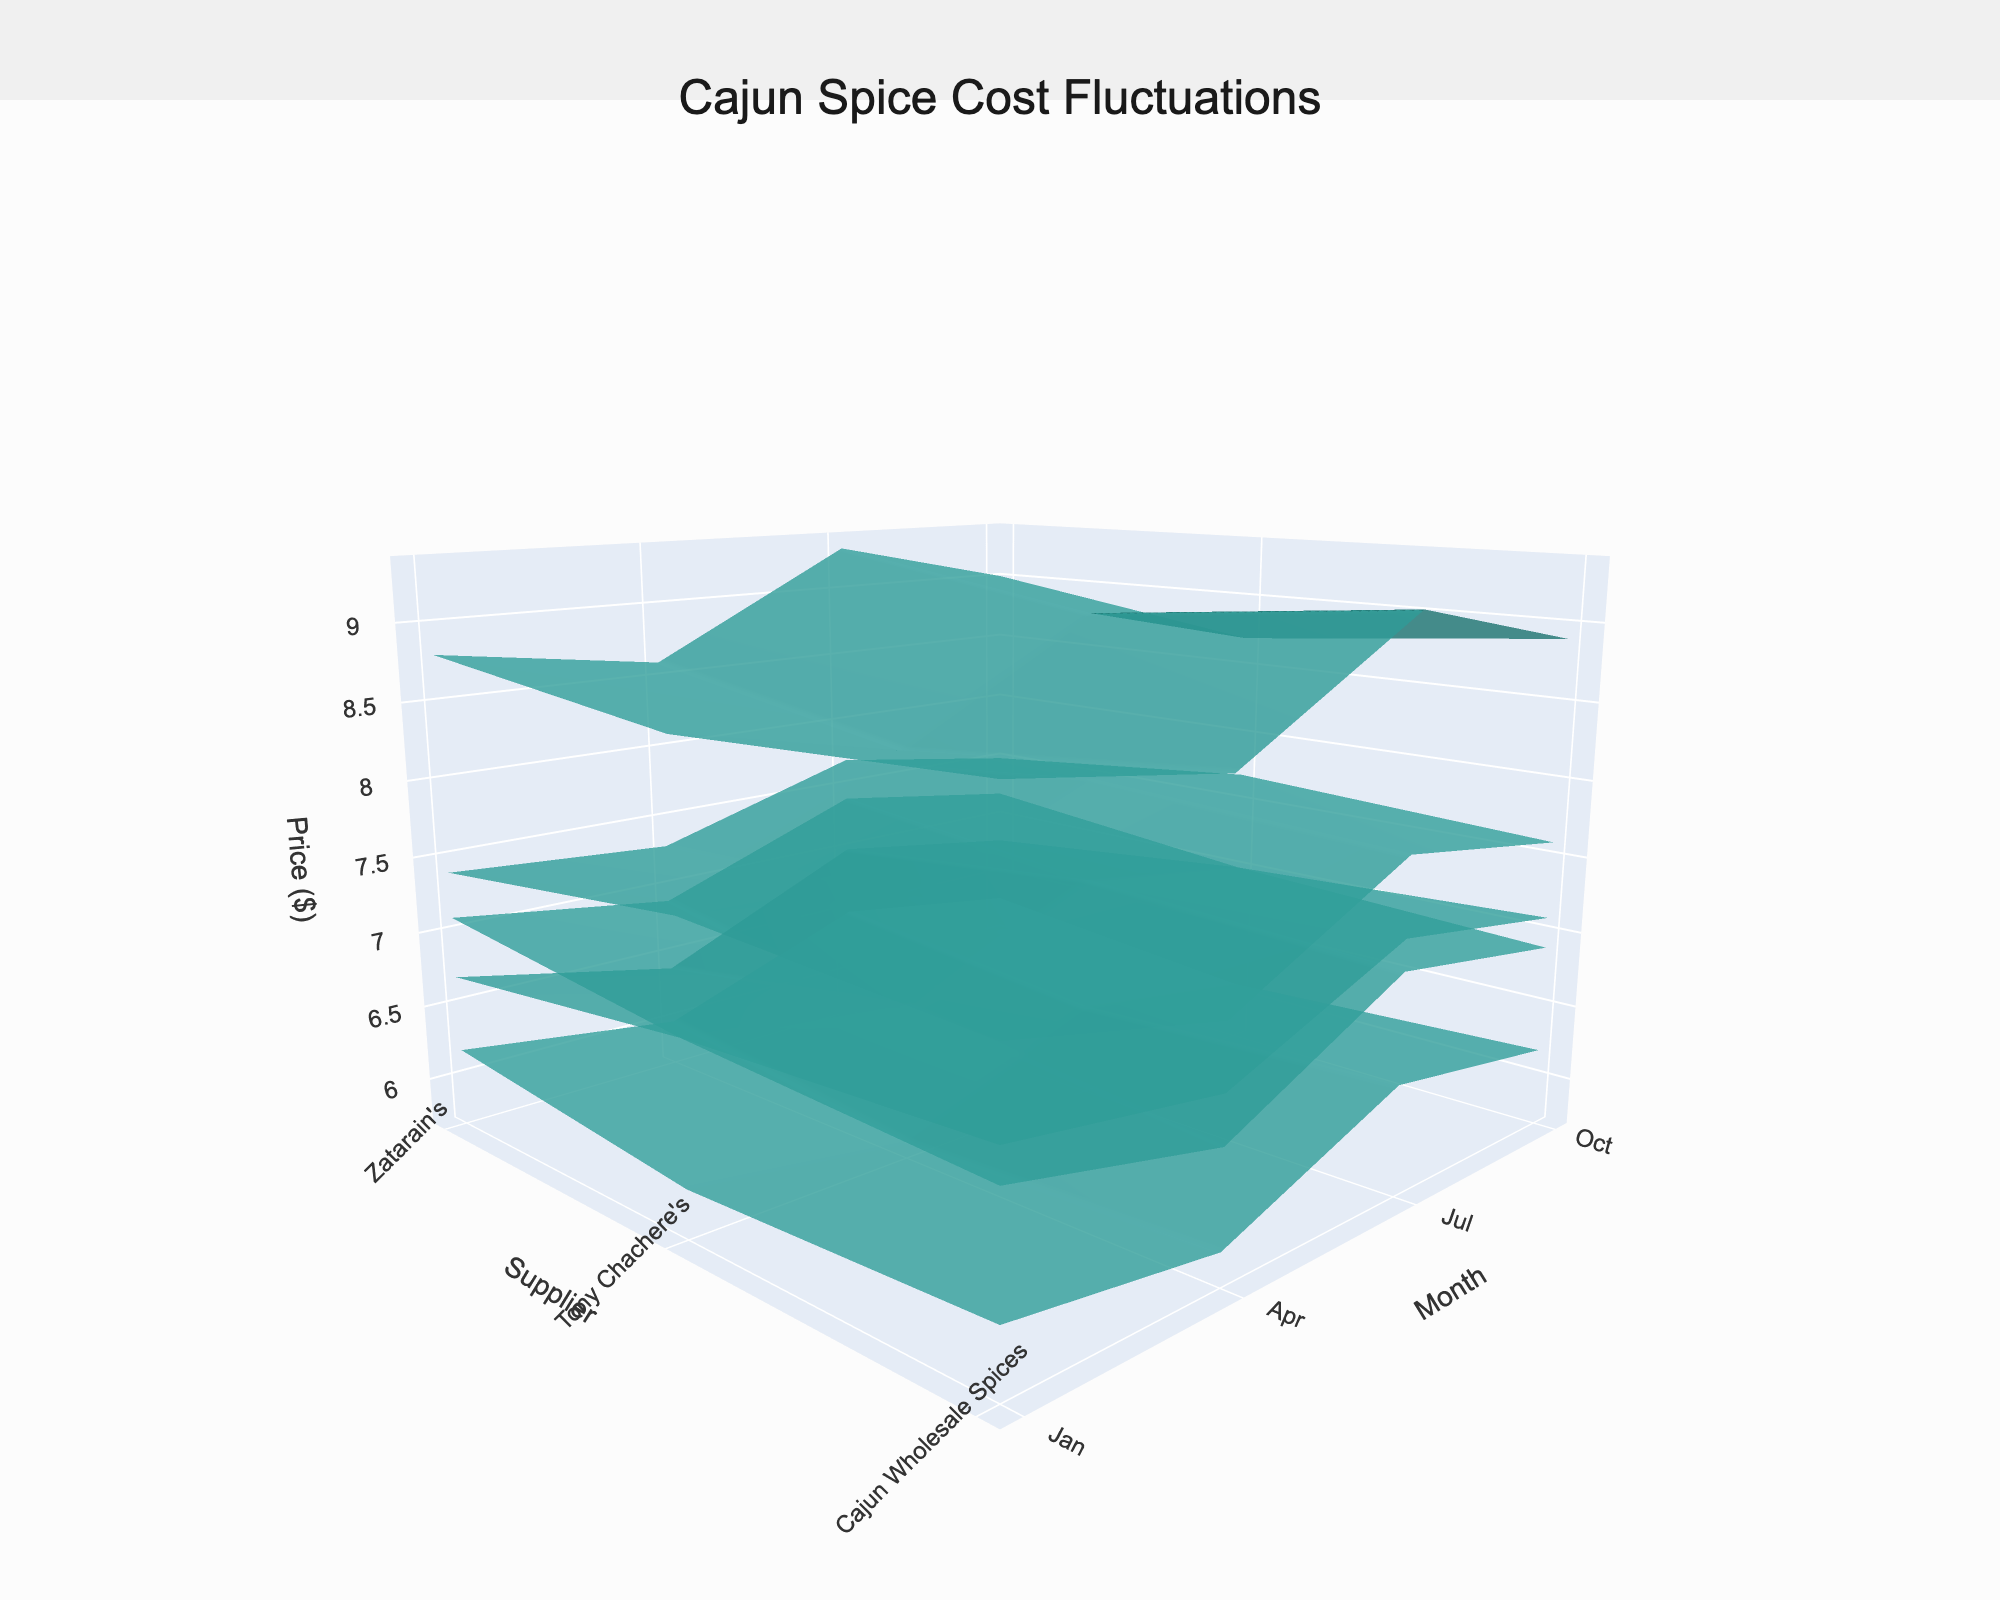What are the suppliers listed along the x-axis? The x-axis displays suppliers, and the figure visually presents their names. They include "Zatarain's", "Tony Chachere's", and "Cajun Wholesale Spices".
Answer: Zatarain's, Tony Chachere's, Cajun Wholesale Spices Which month is the highest point for Zatarain's Cayenne Pepper? To find the highest point for Zatarain's Cayenne Pepper, look at the surface corresponding to Cayenne Pepper, locate Zatarain's on the x-axis, and determine the month with the highest z-value (price). July shows the highest price of $9.20.
Answer: July How does the price of Paprika from Tony Chachere's in January compare to its price in October? Identify the surfaces for Paprika and Tony Chachere's on the x-axis. Compare the height of January's and October's price points on the z-axis. January's price is $7.40, and October's price is $7.70, so it increases.
Answer: October is higher What is the average price of Oregano in April across all suppliers? To calculate the average price of Oregano in April, sum the April prices for all suppliers and divide by the number of suppliers. (6.80 + 6.90 + 6.70) / 3 = 6.80
Answer: $6.80 Which spice shows the least fluctuation in price throughout the year? Observe the surfaces of all spices and assess their z-value range (variation). Garlic Powder shows the least fluctuation as its surface is relatively flat compared to others.
Answer: Garlic Powder Between Zatarain's and Cajun Wholesale Spices, who has the most stable price for Thyme across all months? Compare the z-values for the Thyme surface for both suppliers across all months. Zatarain's has more consistent prices, indicating more stability.
Answer: Zatarain's Is there a general trend in the cost of Cayenne Pepper over the months? Looking at the Cayenne Pepper surface, identify the trend of the z-values over the months. The prices generally increase from January to July but drop somewhat by October.
Answer: Generally increases and then drops in October What is the price difference of Garlic Powder between January and July for Zatarain's? Identify the z-values for Garlic Powder in January and July for Zatarain's on the surface, then calculate the difference: $6.40 - $5.90 = $0.50.
Answer: $0.50 Does Tony Chachere's have higher prices in July compared to January for all spices? Examine the surfaces for each spice, comparing the z-values of Tony Chachere's in July versus January. July prices are higher for all: Cayenne Pepper ($9.00 > $8.30), Paprika ($7.90 > $7.40), Thyme ($7.20 > $6.60), Oregano ($7.20 > $6.70), Garlic Powder ($6.30 > $5.80).
Answer: Yes 